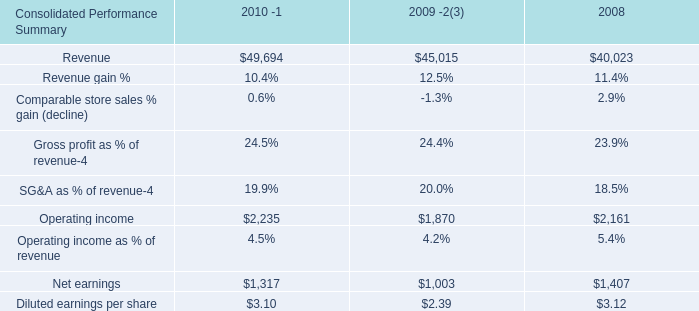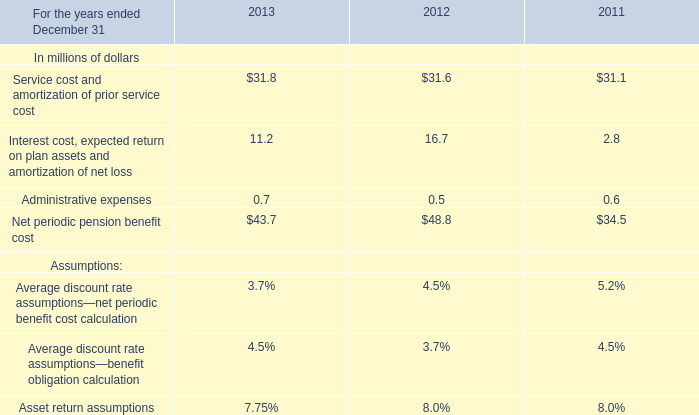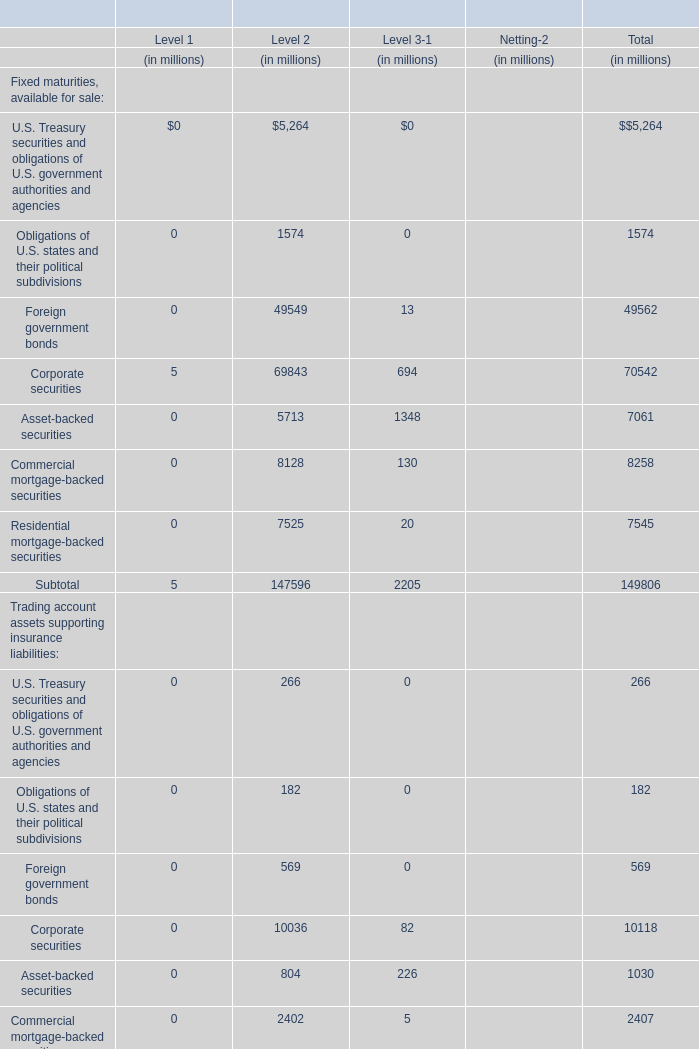What is the sum of Corporate securities, Asset-backed securities and Commercial mortgage-backed securities of Fixed maturities, available for sale for Level 2? (in million) 
Computations: ((69843 + 5713) + 8128)
Answer: 83684.0. 